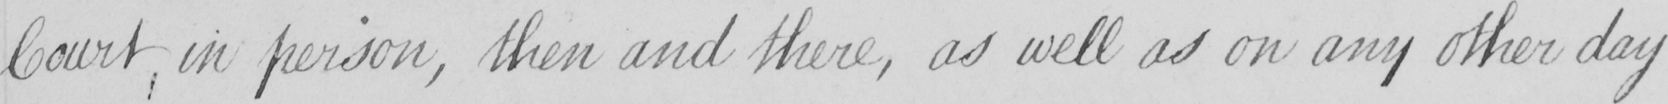Please provide the text content of this handwritten line. Court , in person , then and there , as well as on any other day 